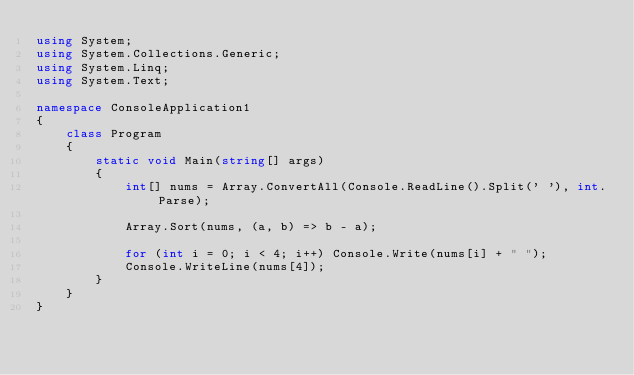Convert code to text. <code><loc_0><loc_0><loc_500><loc_500><_C#_>using System;
using System.Collections.Generic;
using System.Linq;
using System.Text;

namespace ConsoleApplication1
{
    class Program
    {
        static void Main(string[] args)
        {
            int[] nums = Array.ConvertAll(Console.ReadLine().Split(' '), int.Parse);

            Array.Sort(nums, (a, b) => b - a);

            for (int i = 0; i < 4; i++) Console.Write(nums[i] + " ");
            Console.WriteLine(nums[4]);
        }
    }
}</code> 